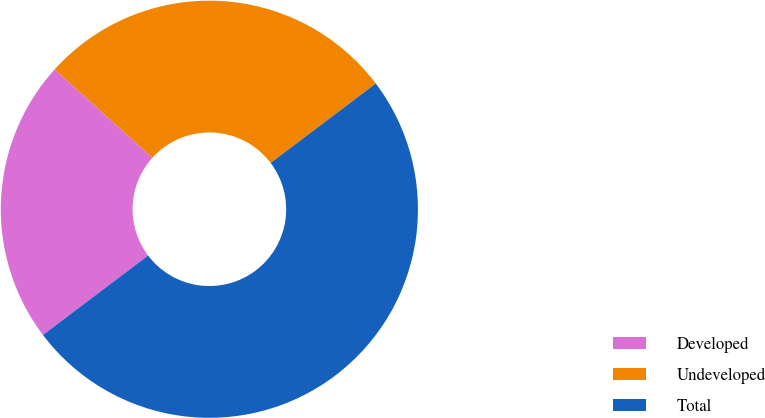Convert chart to OTSL. <chart><loc_0><loc_0><loc_500><loc_500><pie_chart><fcel>Developed<fcel>Undeveloped<fcel>Total<nl><fcel>21.99%<fcel>28.01%<fcel>50.0%<nl></chart> 